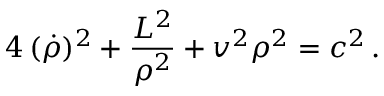Convert formula to latex. <formula><loc_0><loc_0><loc_500><loc_500>4 \, ( \dot { \rho } ) ^ { 2 } + \frac { L ^ { 2 } } { \rho ^ { 2 } } + v ^ { 2 } \rho ^ { 2 } = c ^ { 2 } \, .</formula> 